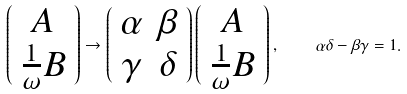Convert formula to latex. <formula><loc_0><loc_0><loc_500><loc_500>\left ( \begin{array} { c } A \\ \frac { 1 } { \omega } B \end{array} \right ) \to \left ( \begin{array} { c c } \alpha & \beta \\ \gamma & \delta \end{array} \right ) \left ( \begin{array} { c } A \\ \frac { 1 } { \omega } B \end{array} \right ) , \quad \alpha \delta - \beta \gamma = 1 .</formula> 